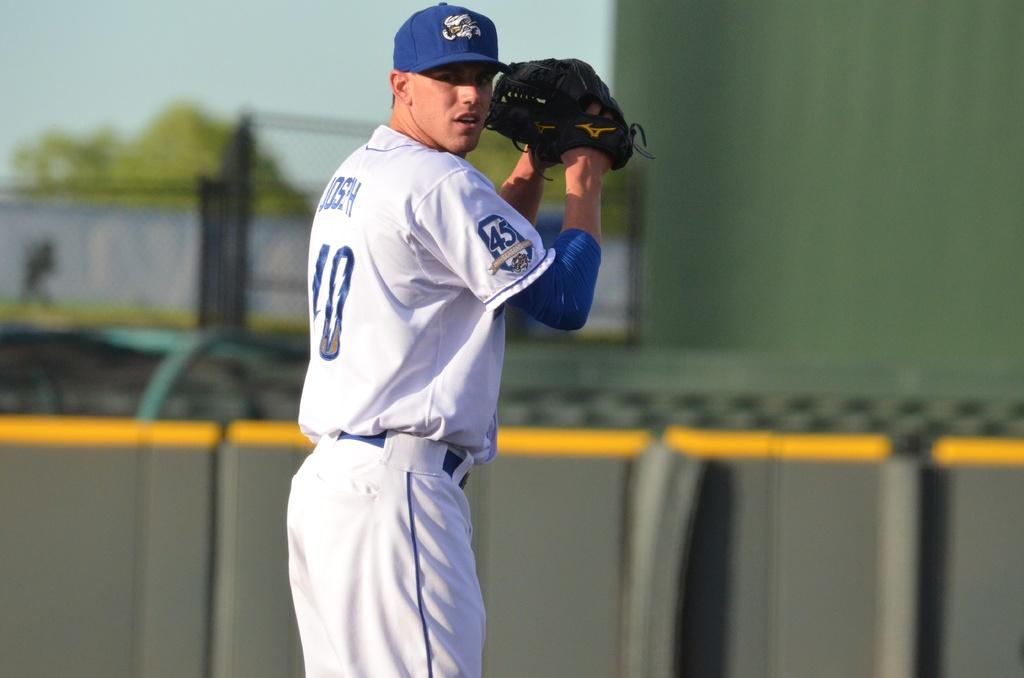<image>
Describe the image concisely. A baseball player with 10 on his jersey about to throw a ball. 